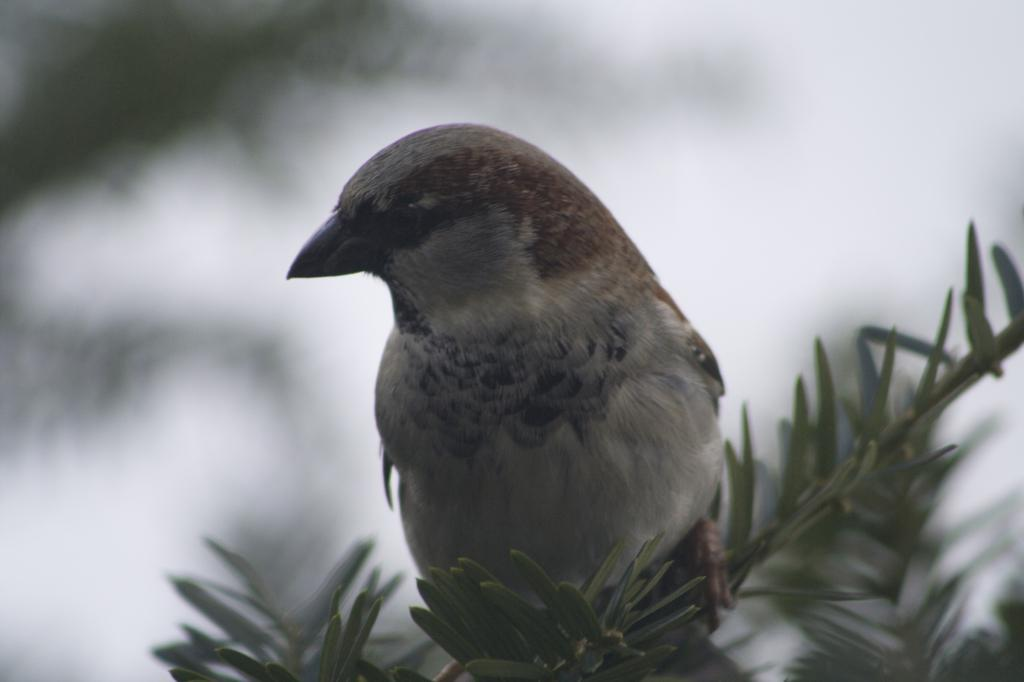What type of animal is present in the image? There is a bird in the image. What can be seen at the bottom of the image? There are leaves at the bottom of the image. How would you describe the background of the image? The background of the image is blurred. What type of competition is the bird participating in within the image? There is no competition present in the image; it simply features a bird and leaves. 